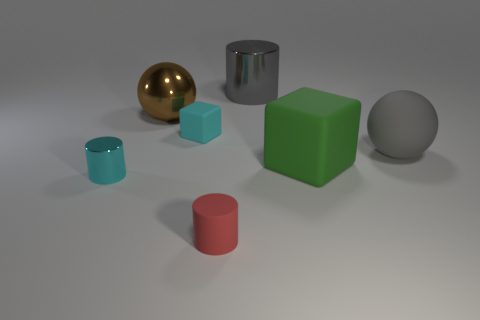Add 2 gray metallic things. How many objects exist? 9 Subtract all spheres. How many objects are left? 5 Add 3 small cyan rubber cubes. How many small cyan rubber cubes exist? 4 Subtract 1 cyan cubes. How many objects are left? 6 Subtract all tiny cyan blocks. Subtract all large brown metallic things. How many objects are left? 5 Add 7 green rubber blocks. How many green rubber blocks are left? 8 